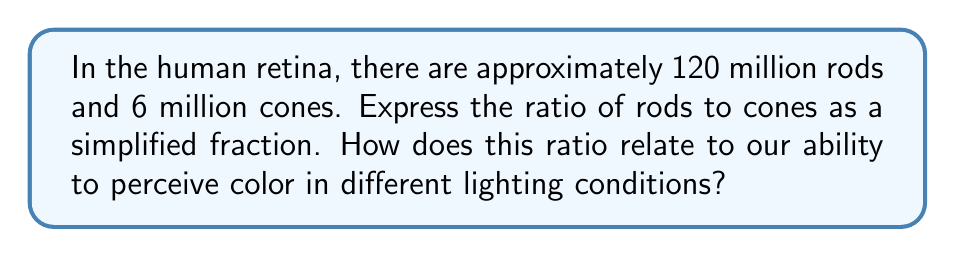Could you help me with this problem? To solve this problem, we need to follow these steps:

1. Identify the given quantities:
   - Number of rods: 120 million
   - Number of cones: 6 million

2. Set up the ratio of rods to cones:
   $$\frac{\text{Number of rods}}{\text{Number of cones}} = \frac{120 \text{ million}}{6 \text{ million}}$$

3. Simplify the ratio by dividing both the numerator and denominator by their greatest common factor:
   $$\frac{120 \text{ million}}{6 \text{ million}} = \frac{120}{6} = \frac{20}{1}$$

4. The simplified ratio is 20:1

Biological significance:
This ratio of 20:1 (rods to cones) explains why humans have different visual capabilities in various lighting conditions:

a) In bright light (photopic vision):
   - Cones are primarily active
   - We can perceive colors accurately
   - Visual acuity is high

b) In low light (scotopic vision):
   - Rods are primarily active
   - Color perception is limited (we see mostly in shades of gray)
   - We can detect movement and shapes, but with less detail

c) In intermediate light (mesopic vision):
   - Both rods and cones are active
   - Color perception is possible but may be less vivid

The higher number of rods allows for better light sensitivity in dim conditions, while the smaller number of cones provides color vision in brighter environments.
Answer: 20:1 